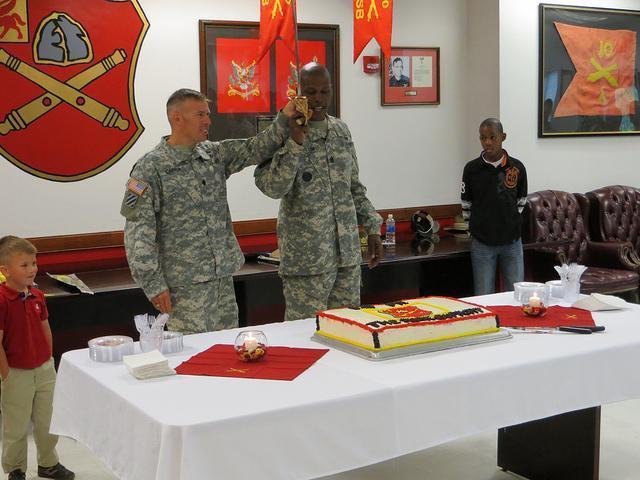How many cakes are there?
Give a very brief answer. 1. How many children are in this photo?
Give a very brief answer. 2. How many chairs are in the picture?
Give a very brief answer. 2. How many people are visible?
Give a very brief answer. 4. How many cars have a surfboard on the roof?
Give a very brief answer. 0. 